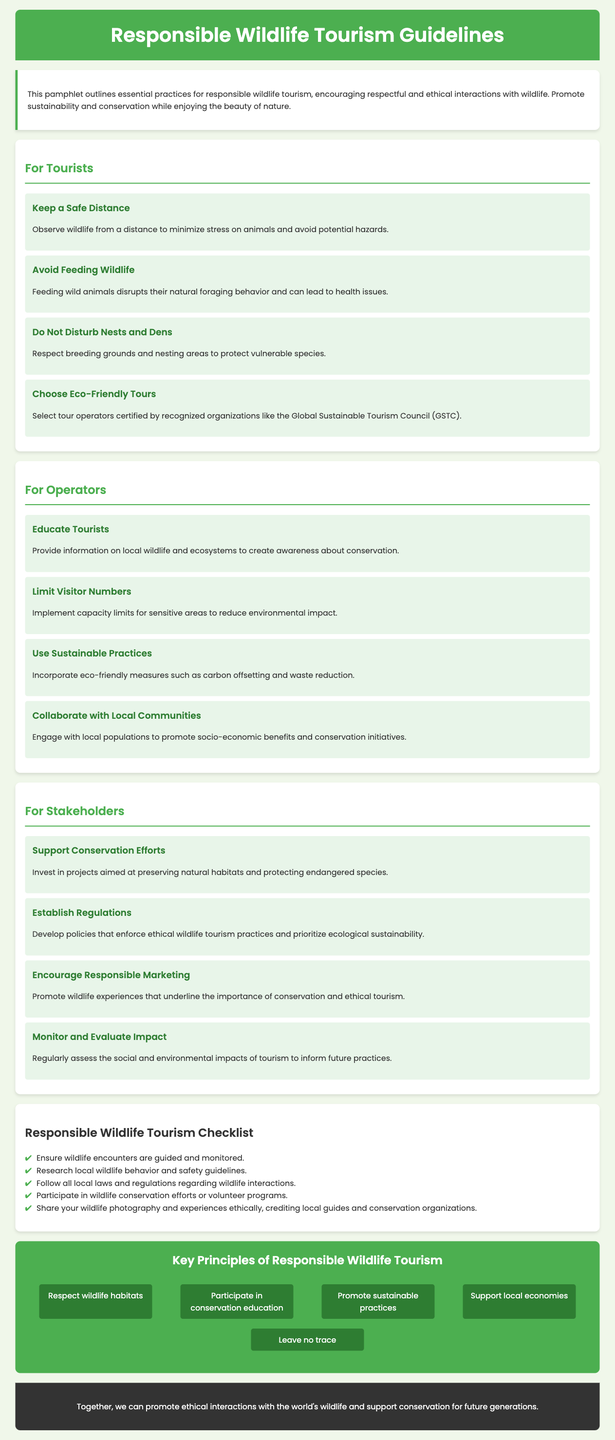what is the title of the document? The title of the document is specified in the header section.
Answer: Responsible Wildlife Tourism Guidelines how many guidelines are for tourists? The number of guidelines for tourists is counted in the section dedicated to them.
Answer: 4 what is one of the key principles of responsible wildlife tourism? One key principle can be found in the infographic section.
Answer: Respect wildlife habitats who should be educated according to the guidelines for operators? The guidelines mention who needs to be educated in the section for operators.
Answer: Tourists what type of practices should operators use? The guidelines specify practices that operators should adopt.
Answer: Sustainable Practices how many checklist items are listed? The number of items in the Responsible Wildlife Tourism Checklist section is counted.
Answer: 5 which organization is mentioned for eco-friendly tour certification? The document includes an organization that certifies tour operators.
Answer: The Global Sustainable Tourism Council (GSTC) what does the footer emphasize? The footer contains a message regarding the document's overall purpose.
Answer: Ethical interactions with wildlife 